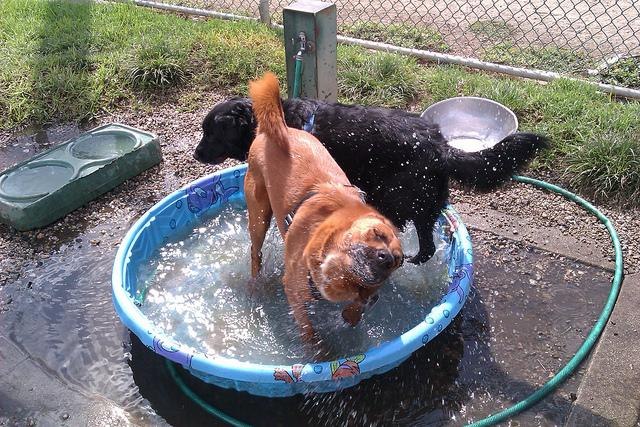What color is the garden hose wrapped around the kiddie pool? green 